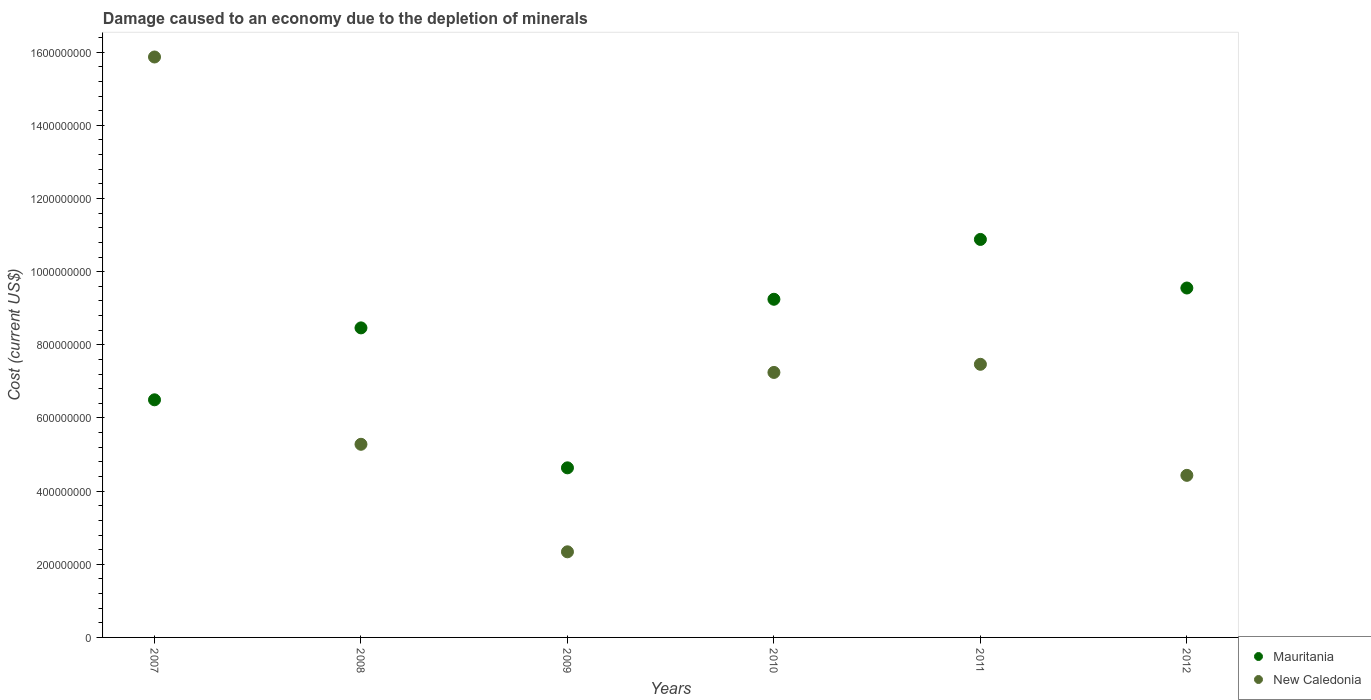How many different coloured dotlines are there?
Ensure brevity in your answer.  2. What is the cost of damage caused due to the depletion of minerals in New Caledonia in 2012?
Give a very brief answer. 4.43e+08. Across all years, what is the maximum cost of damage caused due to the depletion of minerals in Mauritania?
Your answer should be very brief. 1.09e+09. Across all years, what is the minimum cost of damage caused due to the depletion of minerals in New Caledonia?
Offer a terse response. 2.34e+08. In which year was the cost of damage caused due to the depletion of minerals in Mauritania minimum?
Give a very brief answer. 2009. What is the total cost of damage caused due to the depletion of minerals in Mauritania in the graph?
Your answer should be compact. 4.93e+09. What is the difference between the cost of damage caused due to the depletion of minerals in Mauritania in 2007 and that in 2012?
Ensure brevity in your answer.  -3.06e+08. What is the difference between the cost of damage caused due to the depletion of minerals in Mauritania in 2011 and the cost of damage caused due to the depletion of minerals in New Caledonia in 2010?
Your answer should be very brief. 3.64e+08. What is the average cost of damage caused due to the depletion of minerals in Mauritania per year?
Your response must be concise. 8.21e+08. In the year 2007, what is the difference between the cost of damage caused due to the depletion of minerals in Mauritania and cost of damage caused due to the depletion of minerals in New Caledonia?
Provide a succinct answer. -9.37e+08. What is the ratio of the cost of damage caused due to the depletion of minerals in New Caledonia in 2008 to that in 2010?
Offer a very short reply. 0.73. What is the difference between the highest and the second highest cost of damage caused due to the depletion of minerals in New Caledonia?
Offer a terse response. 8.40e+08. What is the difference between the highest and the lowest cost of damage caused due to the depletion of minerals in New Caledonia?
Ensure brevity in your answer.  1.35e+09. In how many years, is the cost of damage caused due to the depletion of minerals in New Caledonia greater than the average cost of damage caused due to the depletion of minerals in New Caledonia taken over all years?
Give a very brief answer. 3. Does the cost of damage caused due to the depletion of minerals in Mauritania monotonically increase over the years?
Your answer should be compact. No. Is the cost of damage caused due to the depletion of minerals in Mauritania strictly greater than the cost of damage caused due to the depletion of minerals in New Caledonia over the years?
Your answer should be compact. No. How many years are there in the graph?
Provide a short and direct response. 6. Does the graph contain grids?
Your response must be concise. No. Where does the legend appear in the graph?
Your response must be concise. Bottom right. How many legend labels are there?
Your response must be concise. 2. What is the title of the graph?
Your answer should be compact. Damage caused to an economy due to the depletion of minerals. What is the label or title of the X-axis?
Make the answer very short. Years. What is the label or title of the Y-axis?
Provide a short and direct response. Cost (current US$). What is the Cost (current US$) of Mauritania in 2007?
Your answer should be compact. 6.50e+08. What is the Cost (current US$) in New Caledonia in 2007?
Ensure brevity in your answer.  1.59e+09. What is the Cost (current US$) in Mauritania in 2008?
Ensure brevity in your answer.  8.46e+08. What is the Cost (current US$) of New Caledonia in 2008?
Ensure brevity in your answer.  5.28e+08. What is the Cost (current US$) in Mauritania in 2009?
Give a very brief answer. 4.64e+08. What is the Cost (current US$) in New Caledonia in 2009?
Ensure brevity in your answer.  2.34e+08. What is the Cost (current US$) in Mauritania in 2010?
Offer a terse response. 9.25e+08. What is the Cost (current US$) in New Caledonia in 2010?
Provide a short and direct response. 7.25e+08. What is the Cost (current US$) of Mauritania in 2011?
Keep it short and to the point. 1.09e+09. What is the Cost (current US$) of New Caledonia in 2011?
Give a very brief answer. 7.47e+08. What is the Cost (current US$) of Mauritania in 2012?
Make the answer very short. 9.55e+08. What is the Cost (current US$) in New Caledonia in 2012?
Your answer should be very brief. 4.43e+08. Across all years, what is the maximum Cost (current US$) of Mauritania?
Give a very brief answer. 1.09e+09. Across all years, what is the maximum Cost (current US$) of New Caledonia?
Your response must be concise. 1.59e+09. Across all years, what is the minimum Cost (current US$) of Mauritania?
Make the answer very short. 4.64e+08. Across all years, what is the minimum Cost (current US$) in New Caledonia?
Provide a succinct answer. 2.34e+08. What is the total Cost (current US$) in Mauritania in the graph?
Provide a short and direct response. 4.93e+09. What is the total Cost (current US$) of New Caledonia in the graph?
Make the answer very short. 4.26e+09. What is the difference between the Cost (current US$) of Mauritania in 2007 and that in 2008?
Offer a terse response. -1.97e+08. What is the difference between the Cost (current US$) of New Caledonia in 2007 and that in 2008?
Ensure brevity in your answer.  1.06e+09. What is the difference between the Cost (current US$) in Mauritania in 2007 and that in 2009?
Your answer should be compact. 1.86e+08. What is the difference between the Cost (current US$) of New Caledonia in 2007 and that in 2009?
Offer a very short reply. 1.35e+09. What is the difference between the Cost (current US$) in Mauritania in 2007 and that in 2010?
Keep it short and to the point. -2.75e+08. What is the difference between the Cost (current US$) in New Caledonia in 2007 and that in 2010?
Give a very brief answer. 8.62e+08. What is the difference between the Cost (current US$) in Mauritania in 2007 and that in 2011?
Offer a terse response. -4.38e+08. What is the difference between the Cost (current US$) in New Caledonia in 2007 and that in 2011?
Ensure brevity in your answer.  8.40e+08. What is the difference between the Cost (current US$) of Mauritania in 2007 and that in 2012?
Your answer should be compact. -3.06e+08. What is the difference between the Cost (current US$) of New Caledonia in 2007 and that in 2012?
Your answer should be compact. 1.14e+09. What is the difference between the Cost (current US$) in Mauritania in 2008 and that in 2009?
Your response must be concise. 3.83e+08. What is the difference between the Cost (current US$) in New Caledonia in 2008 and that in 2009?
Offer a very short reply. 2.94e+08. What is the difference between the Cost (current US$) in Mauritania in 2008 and that in 2010?
Your response must be concise. -7.82e+07. What is the difference between the Cost (current US$) of New Caledonia in 2008 and that in 2010?
Offer a very short reply. -1.96e+08. What is the difference between the Cost (current US$) in Mauritania in 2008 and that in 2011?
Your answer should be very brief. -2.42e+08. What is the difference between the Cost (current US$) of New Caledonia in 2008 and that in 2011?
Offer a very short reply. -2.19e+08. What is the difference between the Cost (current US$) in Mauritania in 2008 and that in 2012?
Your answer should be very brief. -1.09e+08. What is the difference between the Cost (current US$) of New Caledonia in 2008 and that in 2012?
Make the answer very short. 8.49e+07. What is the difference between the Cost (current US$) of Mauritania in 2009 and that in 2010?
Make the answer very short. -4.61e+08. What is the difference between the Cost (current US$) of New Caledonia in 2009 and that in 2010?
Give a very brief answer. -4.90e+08. What is the difference between the Cost (current US$) of Mauritania in 2009 and that in 2011?
Provide a succinct answer. -6.24e+08. What is the difference between the Cost (current US$) of New Caledonia in 2009 and that in 2011?
Offer a very short reply. -5.13e+08. What is the difference between the Cost (current US$) in Mauritania in 2009 and that in 2012?
Offer a very short reply. -4.92e+08. What is the difference between the Cost (current US$) in New Caledonia in 2009 and that in 2012?
Make the answer very short. -2.09e+08. What is the difference between the Cost (current US$) of Mauritania in 2010 and that in 2011?
Your answer should be compact. -1.64e+08. What is the difference between the Cost (current US$) of New Caledonia in 2010 and that in 2011?
Provide a short and direct response. -2.22e+07. What is the difference between the Cost (current US$) of Mauritania in 2010 and that in 2012?
Ensure brevity in your answer.  -3.08e+07. What is the difference between the Cost (current US$) in New Caledonia in 2010 and that in 2012?
Make the answer very short. 2.81e+08. What is the difference between the Cost (current US$) of Mauritania in 2011 and that in 2012?
Ensure brevity in your answer.  1.33e+08. What is the difference between the Cost (current US$) in New Caledonia in 2011 and that in 2012?
Your response must be concise. 3.04e+08. What is the difference between the Cost (current US$) of Mauritania in 2007 and the Cost (current US$) of New Caledonia in 2008?
Ensure brevity in your answer.  1.22e+08. What is the difference between the Cost (current US$) in Mauritania in 2007 and the Cost (current US$) in New Caledonia in 2009?
Keep it short and to the point. 4.16e+08. What is the difference between the Cost (current US$) in Mauritania in 2007 and the Cost (current US$) in New Caledonia in 2010?
Keep it short and to the point. -7.48e+07. What is the difference between the Cost (current US$) in Mauritania in 2007 and the Cost (current US$) in New Caledonia in 2011?
Ensure brevity in your answer.  -9.71e+07. What is the difference between the Cost (current US$) in Mauritania in 2007 and the Cost (current US$) in New Caledonia in 2012?
Offer a terse response. 2.07e+08. What is the difference between the Cost (current US$) in Mauritania in 2008 and the Cost (current US$) in New Caledonia in 2009?
Give a very brief answer. 6.12e+08. What is the difference between the Cost (current US$) in Mauritania in 2008 and the Cost (current US$) in New Caledonia in 2010?
Provide a short and direct response. 1.22e+08. What is the difference between the Cost (current US$) of Mauritania in 2008 and the Cost (current US$) of New Caledonia in 2011?
Give a very brief answer. 9.96e+07. What is the difference between the Cost (current US$) in Mauritania in 2008 and the Cost (current US$) in New Caledonia in 2012?
Offer a terse response. 4.03e+08. What is the difference between the Cost (current US$) in Mauritania in 2009 and the Cost (current US$) in New Caledonia in 2010?
Make the answer very short. -2.61e+08. What is the difference between the Cost (current US$) in Mauritania in 2009 and the Cost (current US$) in New Caledonia in 2011?
Ensure brevity in your answer.  -2.83e+08. What is the difference between the Cost (current US$) of Mauritania in 2009 and the Cost (current US$) of New Caledonia in 2012?
Your answer should be very brief. 2.05e+07. What is the difference between the Cost (current US$) in Mauritania in 2010 and the Cost (current US$) in New Caledonia in 2011?
Keep it short and to the point. 1.78e+08. What is the difference between the Cost (current US$) in Mauritania in 2010 and the Cost (current US$) in New Caledonia in 2012?
Give a very brief answer. 4.81e+08. What is the difference between the Cost (current US$) of Mauritania in 2011 and the Cost (current US$) of New Caledonia in 2012?
Your answer should be very brief. 6.45e+08. What is the average Cost (current US$) in Mauritania per year?
Your answer should be compact. 8.21e+08. What is the average Cost (current US$) in New Caledonia per year?
Provide a short and direct response. 7.11e+08. In the year 2007, what is the difference between the Cost (current US$) in Mauritania and Cost (current US$) in New Caledonia?
Offer a very short reply. -9.37e+08. In the year 2008, what is the difference between the Cost (current US$) in Mauritania and Cost (current US$) in New Caledonia?
Provide a succinct answer. 3.18e+08. In the year 2009, what is the difference between the Cost (current US$) of Mauritania and Cost (current US$) of New Caledonia?
Provide a succinct answer. 2.30e+08. In the year 2010, what is the difference between the Cost (current US$) in Mauritania and Cost (current US$) in New Caledonia?
Offer a terse response. 2.00e+08. In the year 2011, what is the difference between the Cost (current US$) in Mauritania and Cost (current US$) in New Caledonia?
Give a very brief answer. 3.41e+08. In the year 2012, what is the difference between the Cost (current US$) of Mauritania and Cost (current US$) of New Caledonia?
Provide a short and direct response. 5.12e+08. What is the ratio of the Cost (current US$) of Mauritania in 2007 to that in 2008?
Your response must be concise. 0.77. What is the ratio of the Cost (current US$) of New Caledonia in 2007 to that in 2008?
Your answer should be very brief. 3.01. What is the ratio of the Cost (current US$) in Mauritania in 2007 to that in 2009?
Offer a terse response. 1.4. What is the ratio of the Cost (current US$) of New Caledonia in 2007 to that in 2009?
Give a very brief answer. 6.78. What is the ratio of the Cost (current US$) of Mauritania in 2007 to that in 2010?
Your response must be concise. 0.7. What is the ratio of the Cost (current US$) of New Caledonia in 2007 to that in 2010?
Your answer should be very brief. 2.19. What is the ratio of the Cost (current US$) in Mauritania in 2007 to that in 2011?
Ensure brevity in your answer.  0.6. What is the ratio of the Cost (current US$) of New Caledonia in 2007 to that in 2011?
Give a very brief answer. 2.13. What is the ratio of the Cost (current US$) in Mauritania in 2007 to that in 2012?
Your answer should be very brief. 0.68. What is the ratio of the Cost (current US$) in New Caledonia in 2007 to that in 2012?
Keep it short and to the point. 3.58. What is the ratio of the Cost (current US$) of Mauritania in 2008 to that in 2009?
Ensure brevity in your answer.  1.83. What is the ratio of the Cost (current US$) in New Caledonia in 2008 to that in 2009?
Provide a short and direct response. 2.26. What is the ratio of the Cost (current US$) of Mauritania in 2008 to that in 2010?
Offer a very short reply. 0.92. What is the ratio of the Cost (current US$) in New Caledonia in 2008 to that in 2010?
Your response must be concise. 0.73. What is the ratio of the Cost (current US$) of Mauritania in 2008 to that in 2011?
Keep it short and to the point. 0.78. What is the ratio of the Cost (current US$) of New Caledonia in 2008 to that in 2011?
Ensure brevity in your answer.  0.71. What is the ratio of the Cost (current US$) of Mauritania in 2008 to that in 2012?
Offer a terse response. 0.89. What is the ratio of the Cost (current US$) in New Caledonia in 2008 to that in 2012?
Offer a terse response. 1.19. What is the ratio of the Cost (current US$) in Mauritania in 2009 to that in 2010?
Your response must be concise. 0.5. What is the ratio of the Cost (current US$) in New Caledonia in 2009 to that in 2010?
Your response must be concise. 0.32. What is the ratio of the Cost (current US$) in Mauritania in 2009 to that in 2011?
Keep it short and to the point. 0.43. What is the ratio of the Cost (current US$) in New Caledonia in 2009 to that in 2011?
Your response must be concise. 0.31. What is the ratio of the Cost (current US$) of Mauritania in 2009 to that in 2012?
Offer a terse response. 0.49. What is the ratio of the Cost (current US$) of New Caledonia in 2009 to that in 2012?
Give a very brief answer. 0.53. What is the ratio of the Cost (current US$) of Mauritania in 2010 to that in 2011?
Provide a short and direct response. 0.85. What is the ratio of the Cost (current US$) in New Caledonia in 2010 to that in 2011?
Your response must be concise. 0.97. What is the ratio of the Cost (current US$) in Mauritania in 2010 to that in 2012?
Provide a succinct answer. 0.97. What is the ratio of the Cost (current US$) in New Caledonia in 2010 to that in 2012?
Offer a terse response. 1.64. What is the ratio of the Cost (current US$) in Mauritania in 2011 to that in 2012?
Ensure brevity in your answer.  1.14. What is the ratio of the Cost (current US$) of New Caledonia in 2011 to that in 2012?
Keep it short and to the point. 1.69. What is the difference between the highest and the second highest Cost (current US$) in Mauritania?
Make the answer very short. 1.33e+08. What is the difference between the highest and the second highest Cost (current US$) of New Caledonia?
Ensure brevity in your answer.  8.40e+08. What is the difference between the highest and the lowest Cost (current US$) of Mauritania?
Your response must be concise. 6.24e+08. What is the difference between the highest and the lowest Cost (current US$) in New Caledonia?
Offer a very short reply. 1.35e+09. 